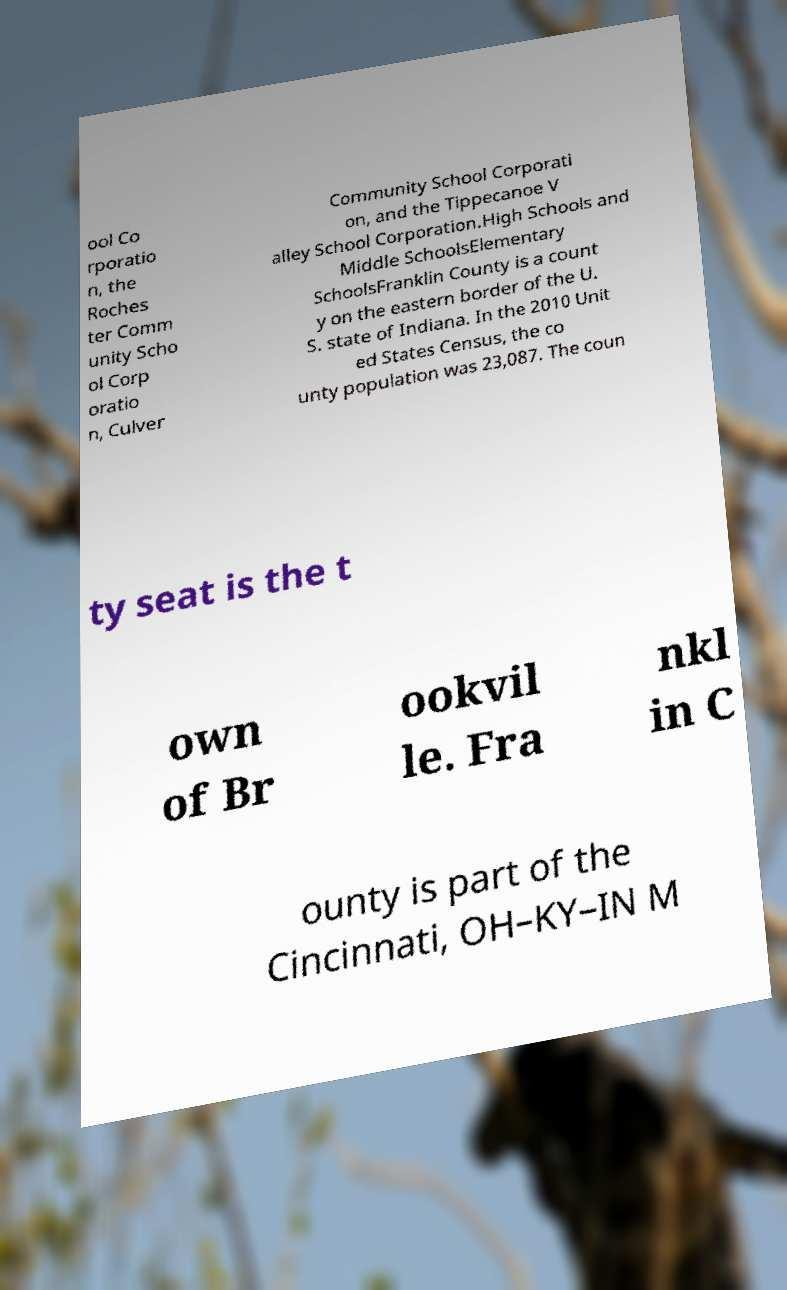For documentation purposes, I need the text within this image transcribed. Could you provide that? ool Co rporatio n, the Roches ter Comm unity Scho ol Corp oratio n, Culver Community School Corporati on, and the Tippecanoe V alley School Corporation.High Schools and Middle SchoolsElementary SchoolsFranklin County is a count y on the eastern border of the U. S. state of Indiana. In the 2010 Unit ed States Census, the co unty population was 23,087. The coun ty seat is the t own of Br ookvil le. Fra nkl in C ounty is part of the Cincinnati, OH–KY–IN M 